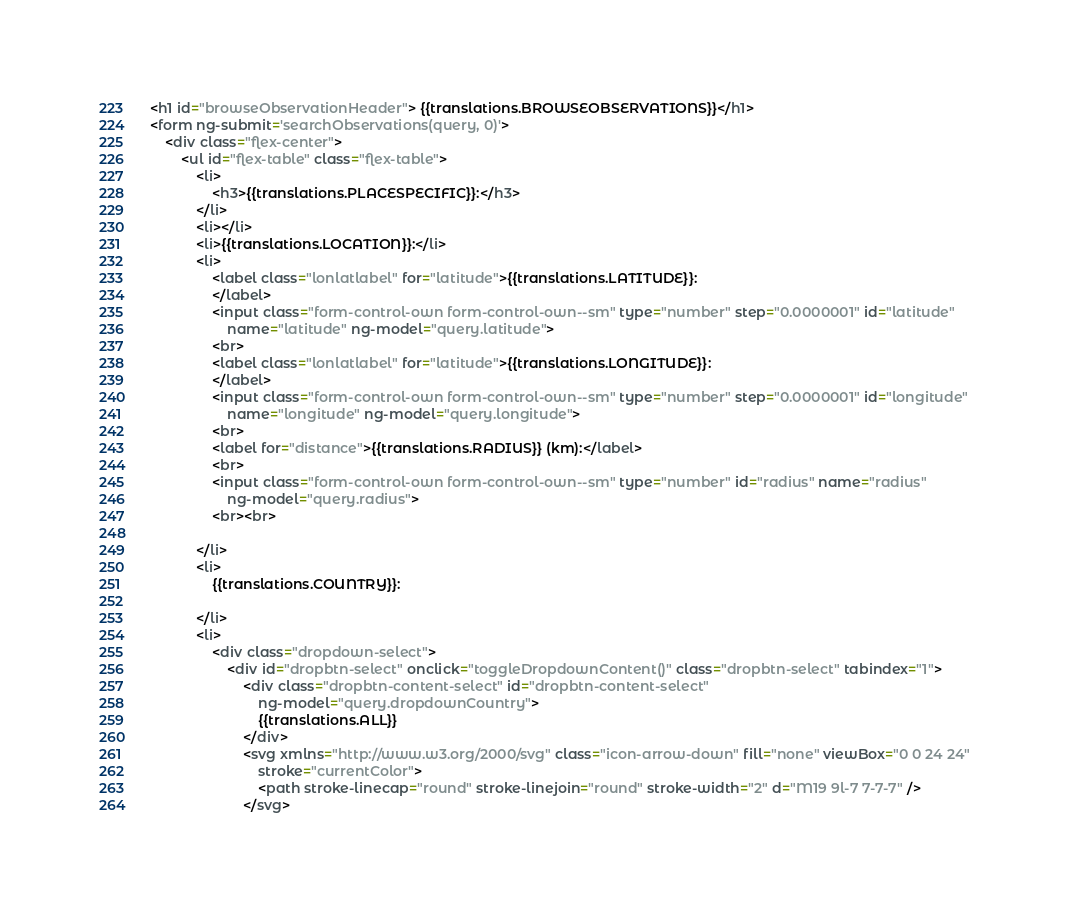Convert code to text. <code><loc_0><loc_0><loc_500><loc_500><_HTML_><h1 id="browseObservationHeader"> {{translations.BROWSEOBSERVATIONS}}</h1>
<form ng-submit='searchObservations(query, 0)'>
	<div class="flex-center">
		<ul id="flex-table" class="flex-table">
			<li>
				<h3>{{translations.PLACESPECIFIC}}:</h3>
			</li>
			<li></li>
			<li>{{translations.LOCATION}}:</li>
			<li>
				<label class="lonlatlabel" for="latitude">{{translations.LATITUDE}}:
				</label>
				<input class="form-control-own form-control-own--sm" type="number" step="0.0000001" id="latitude"
					name="latitude" ng-model="query.latitude">
				<br>
				<label class="lonlatlabel" for="latitude">{{translations.LONGITUDE}}:
				</label>
				<input class="form-control-own form-control-own--sm" type="number" step="0.0000001" id="longitude"
					name="longitude" ng-model="query.longitude">
				<br>
				<label for="distance">{{translations.RADIUS}} (km):</label>
				<br>
				<input class="form-control-own form-control-own--sm" type="number" id="radius" name="radius"
					ng-model="query.radius">
				<br><br>

			</li>
			<li>
				{{translations.COUNTRY}}:

			</li>
			<li>
				<div class="dropdown-select">
					<div id="dropbtn-select" onclick="toggleDropdownContent()" class="dropbtn-select" tabindex="1">
						<div class="dropbtn-content-select" id="dropbtn-content-select"
							ng-model="query.dropdownCountry">
							{{translations.ALL}}
						</div>
						<svg xmlns="http://www.w3.org/2000/svg" class="icon-arrow-down" fill="none" viewBox="0 0 24 24"
							stroke="currentColor">
							<path stroke-linecap="round" stroke-linejoin="round" stroke-width="2" d="M19 9l-7 7-7-7" />
						</svg>
</code> 